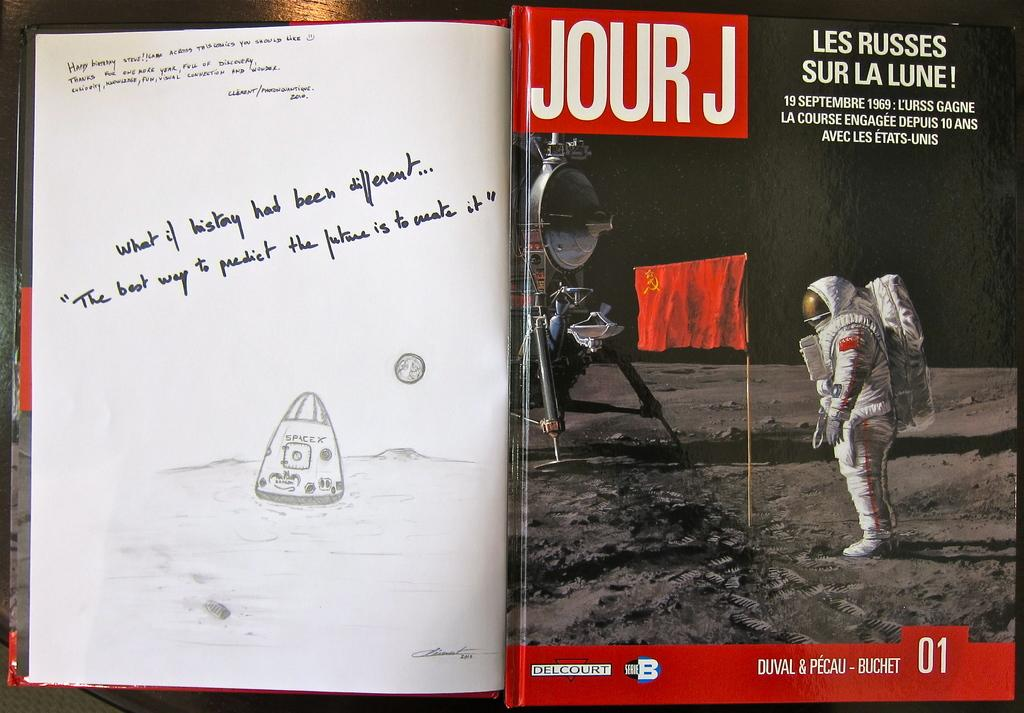<image>
Write a terse but informative summary of the picture. The cover of Jour J magazine showing a moon landing beside a message pondering "What if History had been different" on a white page by the magazine. 